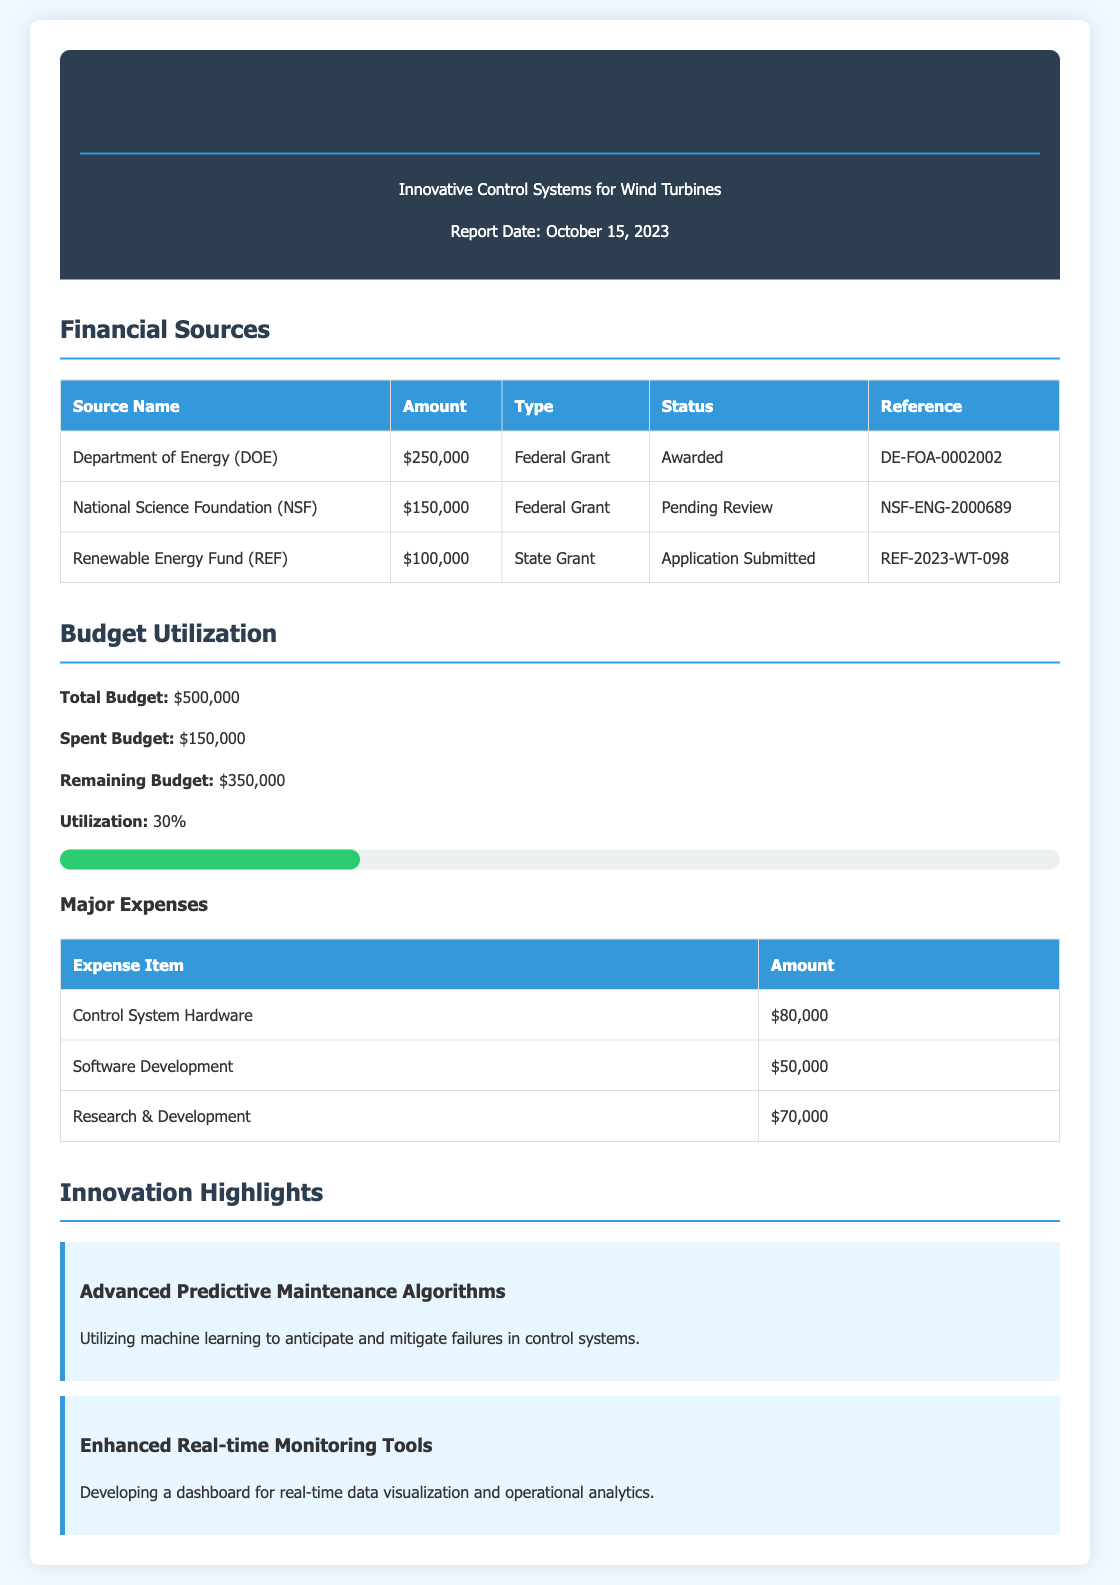What is the total budget? The total budget is explicitly stated in the document under Budget Utilization.
Answer: $500,000 What is the amount received from the Department of Energy? The amount from the Department of Energy is specified in the Financial Sources table.
Answer: $250,000 What is the status of the National Science Foundation application? The status of the NSF application is provided in the Funding Sources section.
Answer: Pending Review How much has been spent from the budget? The amount spent from the budget is clearly stated under Budget Utilization.
Answer: $150,000 What is the remaining budget? The remaining budget is calculated by subtracting the spent budget from the total budget, detailed in the document.
Answer: $350,000 Which expense item incurred the highest cost? The expense items and their amounts are listed, allowing identification of the highest.
Answer: Control System Hardware What innovative feature uses machine learning? The innovations section describes features and their purposes, allowing for identification.
Answer: Advanced Predictive Maintenance Algorithms What is the utilization percentage of the budget? The document explicitly states the utilization percentage under Budget Utilization.
Answer: 30% What are the two main federal grant sources listed? The financial sources section lists all sources, from which two federal grants are identifiable.
Answer: Department of Energy, National Science Foundation 